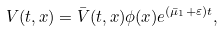Convert formula to latex. <formula><loc_0><loc_0><loc_500><loc_500>V ( t , x ) = \bar { V } ( t , x ) \phi ( x ) e ^ { ( \bar { \mu } _ { 1 } + \varepsilon ) t } ,</formula> 